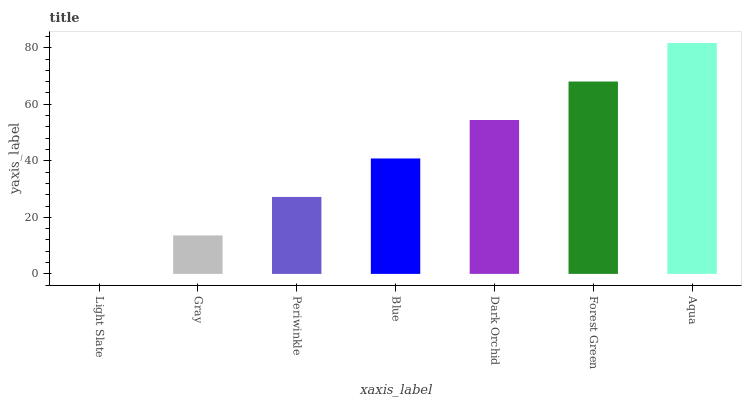Is Light Slate the minimum?
Answer yes or no. Yes. Is Aqua the maximum?
Answer yes or no. Yes. Is Gray the minimum?
Answer yes or no. No. Is Gray the maximum?
Answer yes or no. No. Is Gray greater than Light Slate?
Answer yes or no. Yes. Is Light Slate less than Gray?
Answer yes or no. Yes. Is Light Slate greater than Gray?
Answer yes or no. No. Is Gray less than Light Slate?
Answer yes or no. No. Is Blue the high median?
Answer yes or no. Yes. Is Blue the low median?
Answer yes or no. Yes. Is Periwinkle the high median?
Answer yes or no. No. Is Forest Green the low median?
Answer yes or no. No. 